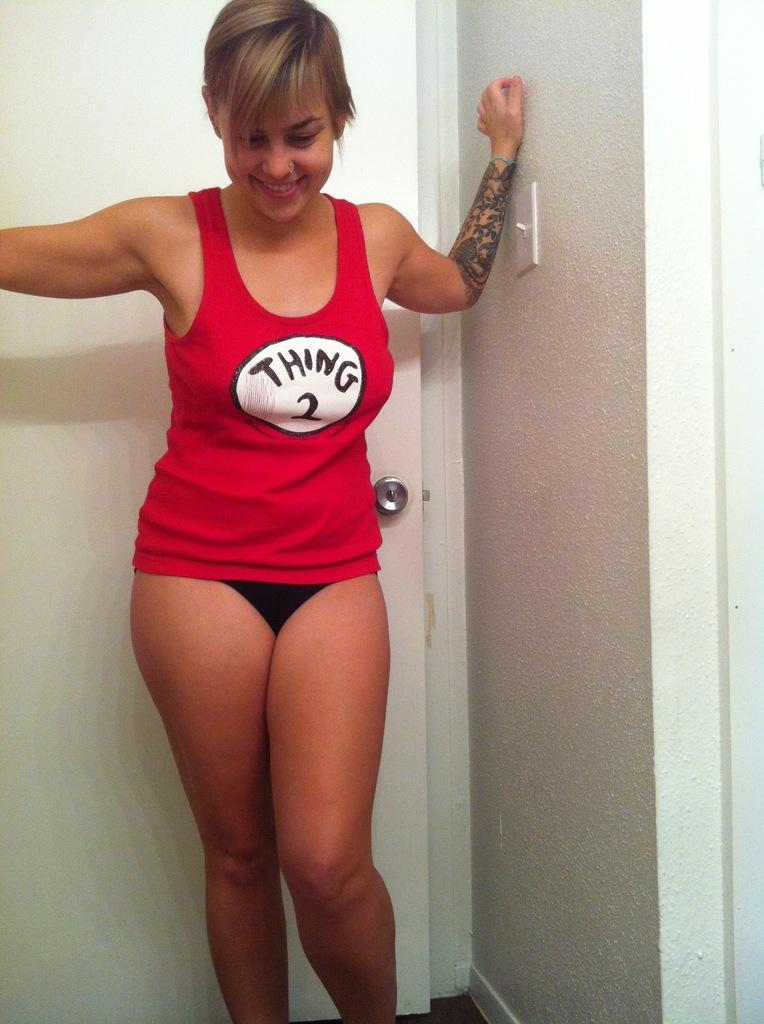<image>
Provide a brief description of the given image. Girl is posing in a thing two shirt and black underwear 